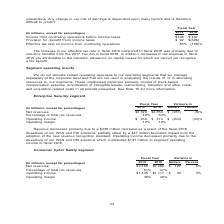According to Nortonlifelock's financial document, What is the increase in effective tax rate in fiscal 2019 compared to fiscal 2018 primarily due to? one-time benefits from the 2017 Tax Act in fiscal 2018. The document states: "2019 compared to fiscal 2018 was primarily due to one-time benefits from the 2017 Tax Act in fiscal 2018. In addition, increases in tax expense in fis..." Also, What is the Income from continuing operations before income taxes for Fiscal 2018? According to the financial document, $437 (in millions). The relevant text states: "continuing operations before income taxes $108 $ 437 Provision for (benefit from) income taxes $ 92 $(690) Effective tax rate on income from continuing..." Also, What is the Income from continuing operations before income taxes for Fiscal 2019? According to the financial document, $108 (in millions). The relevant text states: "ome from continuing operations before income taxes $108 $ 437 Provision for (benefit from) income taxes $ 92 $(690) Effective tax rate on income from contin..." Also, can you calculate: What is the change in Income from continuing operations before income taxes from fiscal 2018 to fiscal 2019? Based on the calculation: 437-108, the result is 329 (in millions). This is based on the information: "e from continuing operations before income taxes $108 $ 437 Provision for (benefit from) income taxes $ 92 $(690) Effective tax rate on income from conti continuing operations before income taxes $108..." The key data points involved are: 108, 437. Also, can you calculate: What is the average  Income from continuing operations before income taxes for fiscal 2019 and fiscal 2018? To answer this question, I need to perform calculations using the financial data. The calculation is: (108+437)/2, which equals 272.5 (in millions). This is based on the information: "e from continuing operations before income taxes $108 $ 437 Provision for (benefit from) income taxes $ 92 $(690) Effective tax rate on income from conti continuing operations before income taxes $108..." The key data points involved are: 108, 437. Also, can you calculate: What is the average  Provision for (benefit from) income taxes? To answer this question, I need to perform calculations using the financial data. The calculation is: (92+(-690))/2, which equals -299 (in millions). This is based on the information: "Provision for (benefit from) income taxes $ 92 $(690) Effective tax rate on income from continuing operations 85% (158)% $ 437 Provision for (benefit from) income taxes $ 92 $(690) Effective tax rate ..." The key data points involved are: 690, 92. 